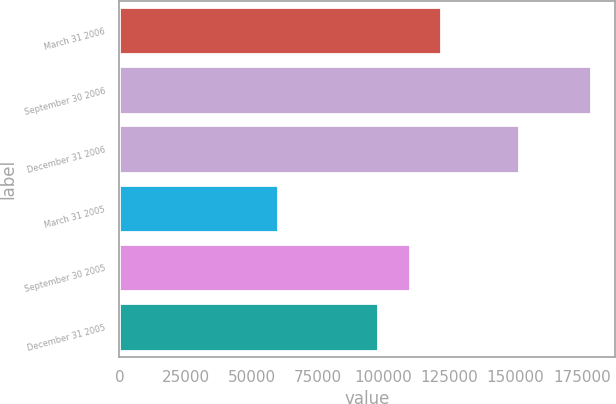<chart> <loc_0><loc_0><loc_500><loc_500><bar_chart><fcel>March 31 2006<fcel>September 30 2006<fcel>December 31 2006<fcel>March 31 2005<fcel>September 30 2005<fcel>December 31 2005<nl><fcel>121737<fcel>178647<fcel>151344<fcel>60014<fcel>109873<fcel>98010<nl></chart> 